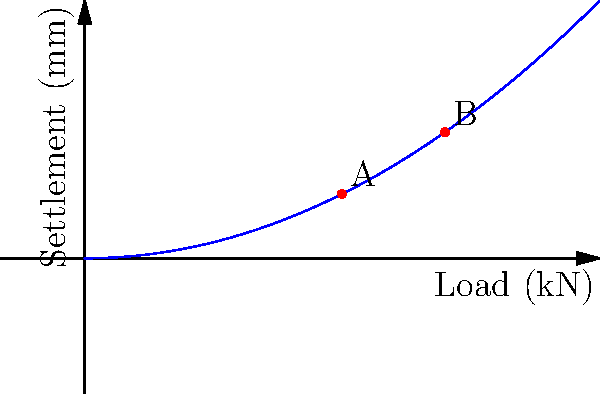In a foundation settlement analysis, the load-settlement curve for a particular soil is shown above. If the load increases from 5 kN (point A) to 7 kN (point B), what is the additional settlement in mm? Round your answer to one decimal place. To solve this problem, we'll follow these steps:

1) The settlement curve is given by the equation $s = 0.05L^2$, where $s$ is the settlement in mm and $L$ is the load in kN.

2) Calculate the settlement at point A (5 kN):
   $s_A = 0.05 * (5)^2 = 1.25$ mm

3) Calculate the settlement at point B (7 kN):
   $s_B = 0.05 * (7)^2 = 2.45$ mm

4) Calculate the difference in settlement:
   $\Delta s = s_B - s_A = 2.45 - 1.25 = 1.20$ mm

5) Round to one decimal place: 1.2 mm

Therefore, the additional settlement when the load increases from 5 kN to 7 kN is 1.2 mm.
Answer: 1.2 mm 